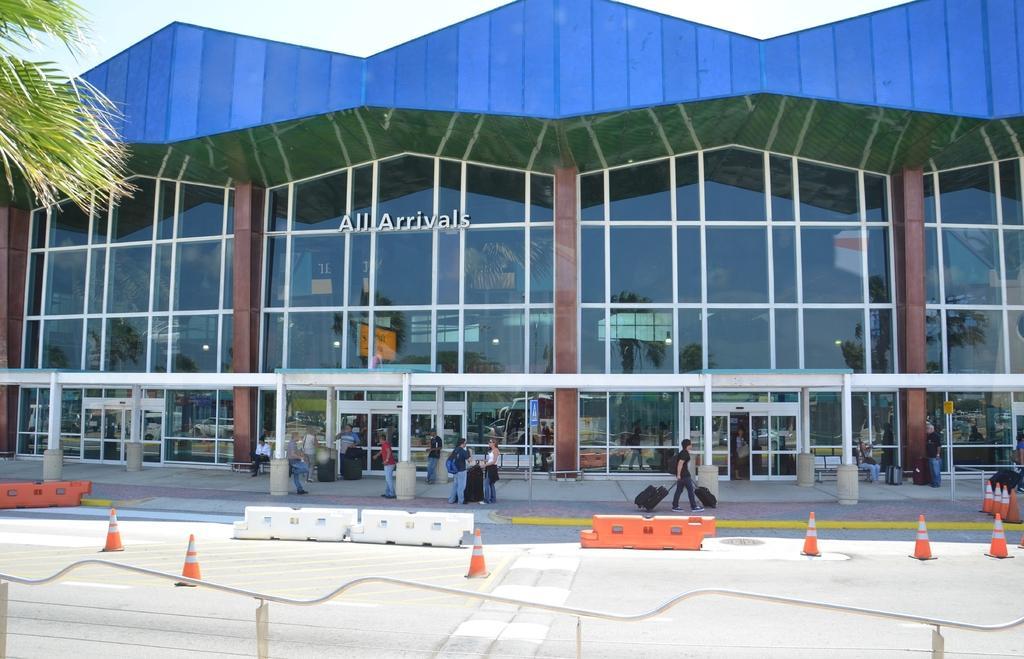Can you describe this image briefly? This picture is taken from the outside of the glass building. In this image, in the middle, we can see a group of people standing and holding their luggage bags. In the left corner, we can also see a tree. At the top, we can see a sky, at the bottom, we can see a road. 